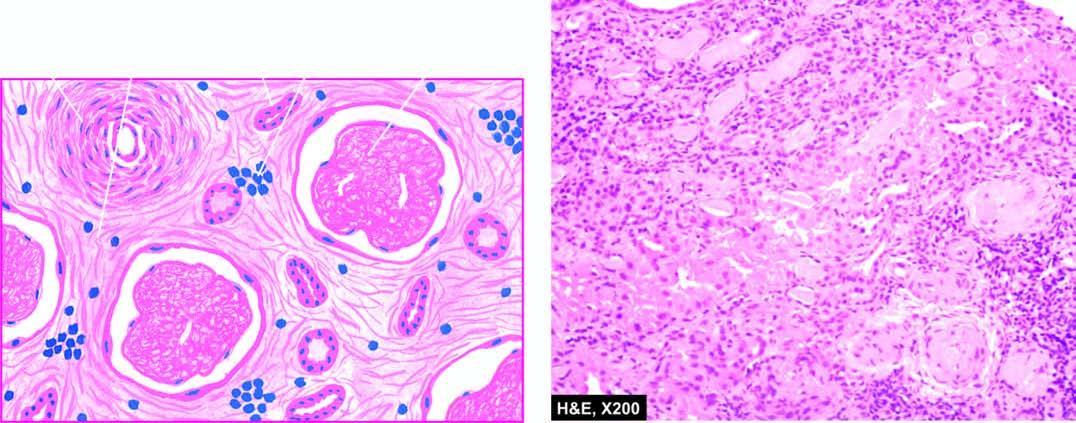does the interstitium show fine fibrosis and a few chronic inflammatory cells?
Answer the question using a single word or phrase. Yes 